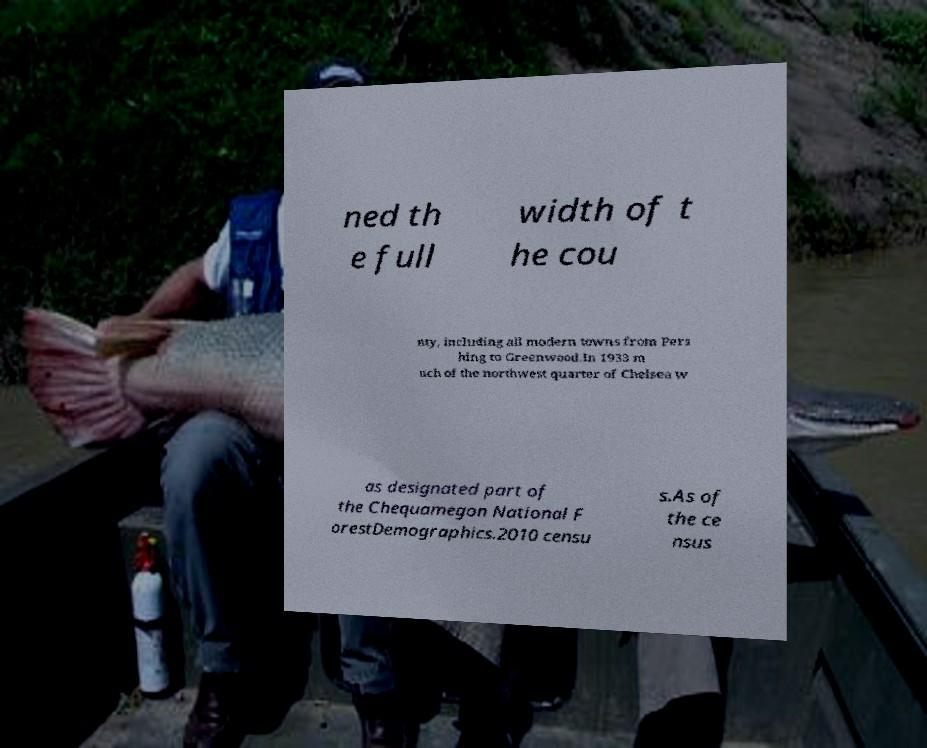Could you extract and type out the text from this image? ned th e full width of t he cou nty, including all modern towns from Pers hing to Greenwood.In 1933 m uch of the northwest quarter of Chelsea w as designated part of the Chequamegon National F orestDemographics.2010 censu s.As of the ce nsus 